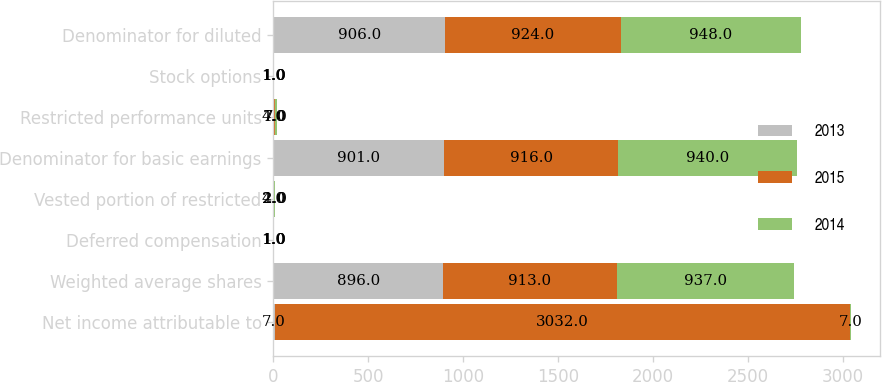<chart> <loc_0><loc_0><loc_500><loc_500><stacked_bar_chart><ecel><fcel>Net income attributable to<fcel>Weighted average shares<fcel>Deferred compensation<fcel>Vested portion of restricted<fcel>Denominator for basic earnings<fcel>Restricted performance units<fcel>Stock options<fcel>Denominator for diluted<nl><fcel>2013<fcel>7<fcel>896<fcel>1<fcel>4<fcel>901<fcel>4<fcel>1<fcel>906<nl><fcel>2015<fcel>3032<fcel>913<fcel>1<fcel>2<fcel>916<fcel>7<fcel>1<fcel>924<nl><fcel>2014<fcel>7<fcel>937<fcel>1<fcel>2<fcel>940<fcel>7<fcel>1<fcel>948<nl></chart> 